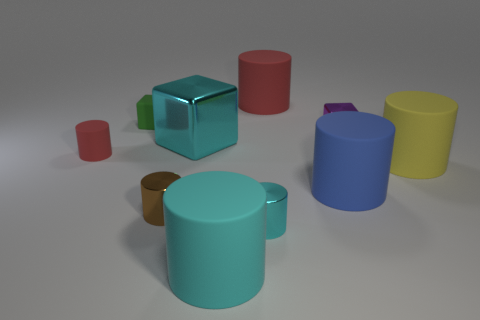Do any of these objects appear to be made of different materials? While I can't physically touch the objects to assess their material, the brown object appears to have a different texture that suggests it could be made of a different material, such as wood, compared to the others that seem to have a smooth plastic or metallic look.  Which object seems out of place based on shape and texture? The brown object appears out of place considering its unique texture and cylindrical shape with a handle, unlike the more geometric shapes of the other objects. 